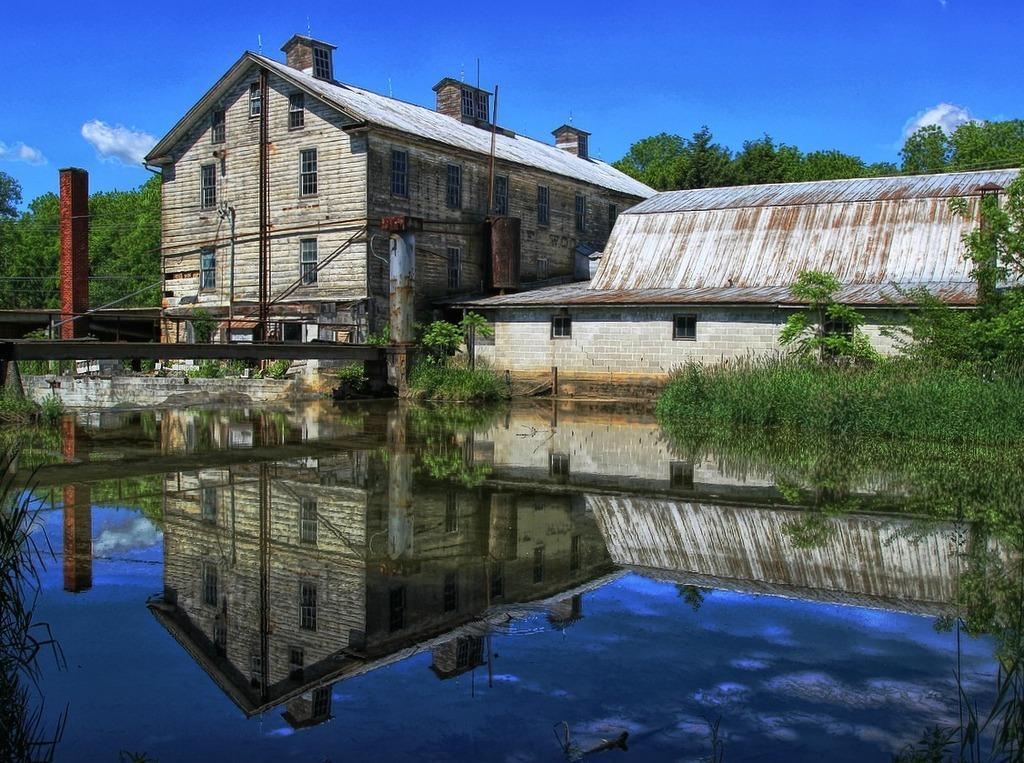What type of natural feature can be seen in the image? There is a river in the image. What is located above the river? There is a metal structure above the river. What type of man-made structures are present in the image? There are buildings in the image. What type of vegetation can be seen in the image? There are trees in the image. What is visible in the background of the image? The sky is visible in the image. How many rats are tied in a knot on the riverbank in the image? There are no rats or knots present in the image. 